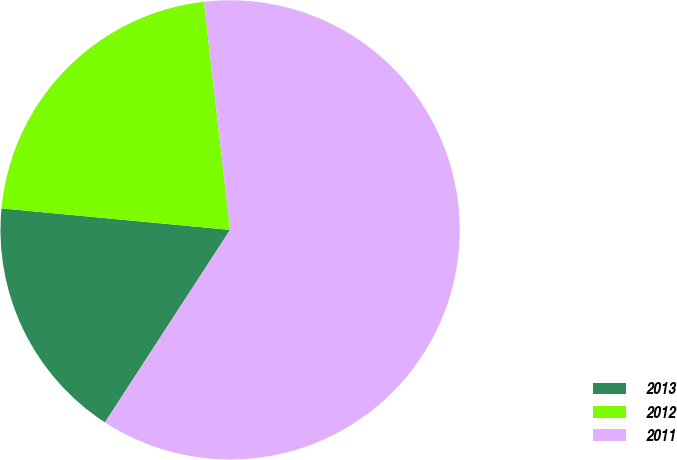Convert chart to OTSL. <chart><loc_0><loc_0><loc_500><loc_500><pie_chart><fcel>2013<fcel>2012<fcel>2011<nl><fcel>17.32%<fcel>21.69%<fcel>60.99%<nl></chart> 